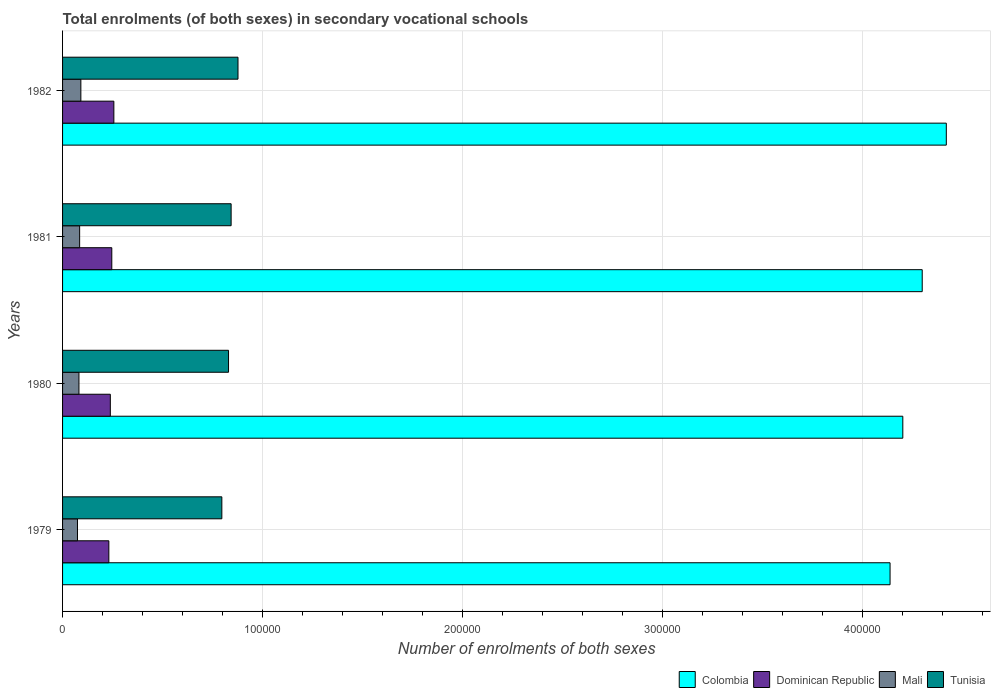Are the number of bars on each tick of the Y-axis equal?
Keep it short and to the point. Yes. How many bars are there on the 3rd tick from the top?
Your answer should be very brief. 4. What is the label of the 3rd group of bars from the top?
Provide a succinct answer. 1980. What is the number of enrolments in secondary schools in Mali in 1979?
Your answer should be very brief. 7461. Across all years, what is the maximum number of enrolments in secondary schools in Tunisia?
Your answer should be very brief. 8.77e+04. Across all years, what is the minimum number of enrolments in secondary schools in Dominican Republic?
Offer a very short reply. 2.31e+04. In which year was the number of enrolments in secondary schools in Colombia minimum?
Make the answer very short. 1979. What is the total number of enrolments in secondary schools in Mali in the graph?
Provide a succinct answer. 3.33e+04. What is the difference between the number of enrolments in secondary schools in Tunisia in 1979 and that in 1982?
Your answer should be compact. -8079. What is the difference between the number of enrolments in secondary schools in Dominican Republic in 1979 and the number of enrolments in secondary schools in Colombia in 1982?
Provide a short and direct response. -4.19e+05. What is the average number of enrolments in secondary schools in Colombia per year?
Your response must be concise. 4.26e+05. In the year 1982, what is the difference between the number of enrolments in secondary schools in Tunisia and number of enrolments in secondary schools in Colombia?
Your response must be concise. -3.54e+05. In how many years, is the number of enrolments in secondary schools in Colombia greater than 280000 ?
Ensure brevity in your answer.  4. What is the ratio of the number of enrolments in secondary schools in Mali in 1981 to that in 1982?
Offer a very short reply. 0.93. What is the difference between the highest and the second highest number of enrolments in secondary schools in Colombia?
Keep it short and to the point. 1.20e+04. What is the difference between the highest and the lowest number of enrolments in secondary schools in Tunisia?
Make the answer very short. 8079. In how many years, is the number of enrolments in secondary schools in Dominican Republic greater than the average number of enrolments in secondary schools in Dominican Republic taken over all years?
Offer a very short reply. 2. Is it the case that in every year, the sum of the number of enrolments in secondary schools in Mali and number of enrolments in secondary schools in Dominican Republic is greater than the sum of number of enrolments in secondary schools in Tunisia and number of enrolments in secondary schools in Colombia?
Provide a short and direct response. No. What does the 2nd bar from the top in 1982 represents?
Your response must be concise. Mali. What does the 2nd bar from the bottom in 1982 represents?
Offer a terse response. Dominican Republic. Is it the case that in every year, the sum of the number of enrolments in secondary schools in Tunisia and number of enrolments in secondary schools in Dominican Republic is greater than the number of enrolments in secondary schools in Mali?
Make the answer very short. Yes. Does the graph contain any zero values?
Keep it short and to the point. No. What is the title of the graph?
Make the answer very short. Total enrolments (of both sexes) in secondary vocational schools. What is the label or title of the X-axis?
Keep it short and to the point. Number of enrolments of both sexes. What is the Number of enrolments of both sexes of Colombia in 1979?
Provide a succinct answer. 4.14e+05. What is the Number of enrolments of both sexes in Dominican Republic in 1979?
Offer a very short reply. 2.31e+04. What is the Number of enrolments of both sexes of Mali in 1979?
Make the answer very short. 7461. What is the Number of enrolments of both sexes in Tunisia in 1979?
Keep it short and to the point. 7.96e+04. What is the Number of enrolments of both sexes of Colombia in 1980?
Keep it short and to the point. 4.20e+05. What is the Number of enrolments of both sexes of Dominican Republic in 1980?
Keep it short and to the point. 2.39e+04. What is the Number of enrolments of both sexes of Mali in 1980?
Give a very brief answer. 8193. What is the Number of enrolments of both sexes of Tunisia in 1980?
Ensure brevity in your answer.  8.30e+04. What is the Number of enrolments of both sexes of Colombia in 1981?
Make the answer very short. 4.30e+05. What is the Number of enrolments of both sexes in Dominican Republic in 1981?
Keep it short and to the point. 2.46e+04. What is the Number of enrolments of both sexes of Mali in 1981?
Offer a very short reply. 8537. What is the Number of enrolments of both sexes in Tunisia in 1981?
Your answer should be compact. 8.43e+04. What is the Number of enrolments of both sexes of Colombia in 1982?
Offer a terse response. 4.42e+05. What is the Number of enrolments of both sexes in Dominican Republic in 1982?
Your answer should be very brief. 2.56e+04. What is the Number of enrolments of both sexes of Mali in 1982?
Make the answer very short. 9150. What is the Number of enrolments of both sexes of Tunisia in 1982?
Provide a short and direct response. 8.77e+04. Across all years, what is the maximum Number of enrolments of both sexes in Colombia?
Ensure brevity in your answer.  4.42e+05. Across all years, what is the maximum Number of enrolments of both sexes in Dominican Republic?
Provide a succinct answer. 2.56e+04. Across all years, what is the maximum Number of enrolments of both sexes of Mali?
Offer a very short reply. 9150. Across all years, what is the maximum Number of enrolments of both sexes in Tunisia?
Your answer should be very brief. 8.77e+04. Across all years, what is the minimum Number of enrolments of both sexes in Colombia?
Provide a short and direct response. 4.14e+05. Across all years, what is the minimum Number of enrolments of both sexes in Dominican Republic?
Offer a very short reply. 2.31e+04. Across all years, what is the minimum Number of enrolments of both sexes in Mali?
Ensure brevity in your answer.  7461. Across all years, what is the minimum Number of enrolments of both sexes in Tunisia?
Your answer should be very brief. 7.96e+04. What is the total Number of enrolments of both sexes of Colombia in the graph?
Give a very brief answer. 1.71e+06. What is the total Number of enrolments of both sexes of Dominican Republic in the graph?
Keep it short and to the point. 9.73e+04. What is the total Number of enrolments of both sexes of Mali in the graph?
Ensure brevity in your answer.  3.33e+04. What is the total Number of enrolments of both sexes of Tunisia in the graph?
Your answer should be compact. 3.35e+05. What is the difference between the Number of enrolments of both sexes of Colombia in 1979 and that in 1980?
Offer a terse response. -6379. What is the difference between the Number of enrolments of both sexes in Dominican Republic in 1979 and that in 1980?
Give a very brief answer. -738. What is the difference between the Number of enrolments of both sexes of Mali in 1979 and that in 1980?
Provide a short and direct response. -732. What is the difference between the Number of enrolments of both sexes in Tunisia in 1979 and that in 1980?
Your response must be concise. -3344. What is the difference between the Number of enrolments of both sexes of Colombia in 1979 and that in 1981?
Give a very brief answer. -1.61e+04. What is the difference between the Number of enrolments of both sexes of Dominican Republic in 1979 and that in 1981?
Offer a very short reply. -1476. What is the difference between the Number of enrolments of both sexes of Mali in 1979 and that in 1981?
Make the answer very short. -1076. What is the difference between the Number of enrolments of both sexes of Tunisia in 1979 and that in 1981?
Provide a succinct answer. -4643. What is the difference between the Number of enrolments of both sexes in Colombia in 1979 and that in 1982?
Offer a terse response. -2.81e+04. What is the difference between the Number of enrolments of both sexes in Dominican Republic in 1979 and that in 1982?
Keep it short and to the point. -2504. What is the difference between the Number of enrolments of both sexes of Mali in 1979 and that in 1982?
Your response must be concise. -1689. What is the difference between the Number of enrolments of both sexes in Tunisia in 1979 and that in 1982?
Your response must be concise. -8079. What is the difference between the Number of enrolments of both sexes in Colombia in 1980 and that in 1981?
Offer a terse response. -9705. What is the difference between the Number of enrolments of both sexes in Dominican Republic in 1980 and that in 1981?
Provide a short and direct response. -738. What is the difference between the Number of enrolments of both sexes in Mali in 1980 and that in 1981?
Your answer should be very brief. -344. What is the difference between the Number of enrolments of both sexes of Tunisia in 1980 and that in 1981?
Provide a succinct answer. -1299. What is the difference between the Number of enrolments of both sexes of Colombia in 1980 and that in 1982?
Your answer should be compact. -2.17e+04. What is the difference between the Number of enrolments of both sexes in Dominican Republic in 1980 and that in 1982?
Ensure brevity in your answer.  -1766. What is the difference between the Number of enrolments of both sexes of Mali in 1980 and that in 1982?
Provide a succinct answer. -957. What is the difference between the Number of enrolments of both sexes in Tunisia in 1980 and that in 1982?
Your answer should be compact. -4735. What is the difference between the Number of enrolments of both sexes of Colombia in 1981 and that in 1982?
Offer a terse response. -1.20e+04. What is the difference between the Number of enrolments of both sexes in Dominican Republic in 1981 and that in 1982?
Ensure brevity in your answer.  -1028. What is the difference between the Number of enrolments of both sexes of Mali in 1981 and that in 1982?
Offer a terse response. -613. What is the difference between the Number of enrolments of both sexes in Tunisia in 1981 and that in 1982?
Your answer should be very brief. -3436. What is the difference between the Number of enrolments of both sexes of Colombia in 1979 and the Number of enrolments of both sexes of Dominican Republic in 1980?
Offer a terse response. 3.90e+05. What is the difference between the Number of enrolments of both sexes in Colombia in 1979 and the Number of enrolments of both sexes in Mali in 1980?
Offer a terse response. 4.06e+05. What is the difference between the Number of enrolments of both sexes of Colombia in 1979 and the Number of enrolments of both sexes of Tunisia in 1980?
Provide a short and direct response. 3.31e+05. What is the difference between the Number of enrolments of both sexes in Dominican Republic in 1979 and the Number of enrolments of both sexes in Mali in 1980?
Provide a short and direct response. 1.50e+04. What is the difference between the Number of enrolments of both sexes in Dominican Republic in 1979 and the Number of enrolments of both sexes in Tunisia in 1980?
Your answer should be very brief. -5.98e+04. What is the difference between the Number of enrolments of both sexes in Mali in 1979 and the Number of enrolments of both sexes in Tunisia in 1980?
Give a very brief answer. -7.55e+04. What is the difference between the Number of enrolments of both sexes of Colombia in 1979 and the Number of enrolments of both sexes of Dominican Republic in 1981?
Provide a succinct answer. 3.89e+05. What is the difference between the Number of enrolments of both sexes of Colombia in 1979 and the Number of enrolments of both sexes of Mali in 1981?
Keep it short and to the point. 4.05e+05. What is the difference between the Number of enrolments of both sexes in Colombia in 1979 and the Number of enrolments of both sexes in Tunisia in 1981?
Offer a very short reply. 3.30e+05. What is the difference between the Number of enrolments of both sexes of Dominican Republic in 1979 and the Number of enrolments of both sexes of Mali in 1981?
Provide a short and direct response. 1.46e+04. What is the difference between the Number of enrolments of both sexes in Dominican Republic in 1979 and the Number of enrolments of both sexes in Tunisia in 1981?
Your answer should be compact. -6.11e+04. What is the difference between the Number of enrolments of both sexes of Mali in 1979 and the Number of enrolments of both sexes of Tunisia in 1981?
Keep it short and to the point. -7.68e+04. What is the difference between the Number of enrolments of both sexes of Colombia in 1979 and the Number of enrolments of both sexes of Dominican Republic in 1982?
Give a very brief answer. 3.88e+05. What is the difference between the Number of enrolments of both sexes of Colombia in 1979 and the Number of enrolments of both sexes of Mali in 1982?
Provide a succinct answer. 4.05e+05. What is the difference between the Number of enrolments of both sexes in Colombia in 1979 and the Number of enrolments of both sexes in Tunisia in 1982?
Make the answer very short. 3.26e+05. What is the difference between the Number of enrolments of both sexes of Dominican Republic in 1979 and the Number of enrolments of both sexes of Mali in 1982?
Offer a terse response. 1.40e+04. What is the difference between the Number of enrolments of both sexes in Dominican Republic in 1979 and the Number of enrolments of both sexes in Tunisia in 1982?
Keep it short and to the point. -6.46e+04. What is the difference between the Number of enrolments of both sexes in Mali in 1979 and the Number of enrolments of both sexes in Tunisia in 1982?
Provide a succinct answer. -8.03e+04. What is the difference between the Number of enrolments of both sexes in Colombia in 1980 and the Number of enrolments of both sexes in Dominican Republic in 1981?
Provide a short and direct response. 3.96e+05. What is the difference between the Number of enrolments of both sexes in Colombia in 1980 and the Number of enrolments of both sexes in Mali in 1981?
Your answer should be compact. 4.12e+05. What is the difference between the Number of enrolments of both sexes of Colombia in 1980 and the Number of enrolments of both sexes of Tunisia in 1981?
Offer a terse response. 3.36e+05. What is the difference between the Number of enrolments of both sexes of Dominican Republic in 1980 and the Number of enrolments of both sexes of Mali in 1981?
Offer a very short reply. 1.53e+04. What is the difference between the Number of enrolments of both sexes of Dominican Republic in 1980 and the Number of enrolments of both sexes of Tunisia in 1981?
Your answer should be compact. -6.04e+04. What is the difference between the Number of enrolments of both sexes of Mali in 1980 and the Number of enrolments of both sexes of Tunisia in 1981?
Provide a short and direct response. -7.61e+04. What is the difference between the Number of enrolments of both sexes of Colombia in 1980 and the Number of enrolments of both sexes of Dominican Republic in 1982?
Give a very brief answer. 3.95e+05. What is the difference between the Number of enrolments of both sexes of Colombia in 1980 and the Number of enrolments of both sexes of Mali in 1982?
Make the answer very short. 4.11e+05. What is the difference between the Number of enrolments of both sexes in Colombia in 1980 and the Number of enrolments of both sexes in Tunisia in 1982?
Keep it short and to the point. 3.32e+05. What is the difference between the Number of enrolments of both sexes in Dominican Republic in 1980 and the Number of enrolments of both sexes in Mali in 1982?
Keep it short and to the point. 1.47e+04. What is the difference between the Number of enrolments of both sexes in Dominican Republic in 1980 and the Number of enrolments of both sexes in Tunisia in 1982?
Your answer should be compact. -6.38e+04. What is the difference between the Number of enrolments of both sexes of Mali in 1980 and the Number of enrolments of both sexes of Tunisia in 1982?
Offer a terse response. -7.95e+04. What is the difference between the Number of enrolments of both sexes of Colombia in 1981 and the Number of enrolments of both sexes of Dominican Republic in 1982?
Provide a succinct answer. 4.04e+05. What is the difference between the Number of enrolments of both sexes in Colombia in 1981 and the Number of enrolments of both sexes in Mali in 1982?
Offer a terse response. 4.21e+05. What is the difference between the Number of enrolments of both sexes in Colombia in 1981 and the Number of enrolments of both sexes in Tunisia in 1982?
Keep it short and to the point. 3.42e+05. What is the difference between the Number of enrolments of both sexes of Dominican Republic in 1981 and the Number of enrolments of both sexes of Mali in 1982?
Give a very brief answer. 1.55e+04. What is the difference between the Number of enrolments of both sexes of Dominican Republic in 1981 and the Number of enrolments of both sexes of Tunisia in 1982?
Provide a short and direct response. -6.31e+04. What is the difference between the Number of enrolments of both sexes in Mali in 1981 and the Number of enrolments of both sexes in Tunisia in 1982?
Provide a succinct answer. -7.92e+04. What is the average Number of enrolments of both sexes of Colombia per year?
Your answer should be very brief. 4.26e+05. What is the average Number of enrolments of both sexes of Dominican Republic per year?
Your answer should be very brief. 2.43e+04. What is the average Number of enrolments of both sexes in Mali per year?
Provide a succinct answer. 8335.25. What is the average Number of enrolments of both sexes of Tunisia per year?
Give a very brief answer. 8.37e+04. In the year 1979, what is the difference between the Number of enrolments of both sexes of Colombia and Number of enrolments of both sexes of Dominican Republic?
Provide a short and direct response. 3.91e+05. In the year 1979, what is the difference between the Number of enrolments of both sexes in Colombia and Number of enrolments of both sexes in Mali?
Your answer should be compact. 4.06e+05. In the year 1979, what is the difference between the Number of enrolments of both sexes in Colombia and Number of enrolments of both sexes in Tunisia?
Offer a very short reply. 3.34e+05. In the year 1979, what is the difference between the Number of enrolments of both sexes of Dominican Republic and Number of enrolments of both sexes of Mali?
Give a very brief answer. 1.57e+04. In the year 1979, what is the difference between the Number of enrolments of both sexes in Dominican Republic and Number of enrolments of both sexes in Tunisia?
Keep it short and to the point. -5.65e+04. In the year 1979, what is the difference between the Number of enrolments of both sexes in Mali and Number of enrolments of both sexes in Tunisia?
Keep it short and to the point. -7.22e+04. In the year 1980, what is the difference between the Number of enrolments of both sexes in Colombia and Number of enrolments of both sexes in Dominican Republic?
Keep it short and to the point. 3.96e+05. In the year 1980, what is the difference between the Number of enrolments of both sexes of Colombia and Number of enrolments of both sexes of Mali?
Provide a short and direct response. 4.12e+05. In the year 1980, what is the difference between the Number of enrolments of both sexes of Colombia and Number of enrolments of both sexes of Tunisia?
Give a very brief answer. 3.37e+05. In the year 1980, what is the difference between the Number of enrolments of both sexes in Dominican Republic and Number of enrolments of both sexes in Mali?
Your answer should be compact. 1.57e+04. In the year 1980, what is the difference between the Number of enrolments of both sexes of Dominican Republic and Number of enrolments of both sexes of Tunisia?
Give a very brief answer. -5.91e+04. In the year 1980, what is the difference between the Number of enrolments of both sexes of Mali and Number of enrolments of both sexes of Tunisia?
Keep it short and to the point. -7.48e+04. In the year 1981, what is the difference between the Number of enrolments of both sexes in Colombia and Number of enrolments of both sexes in Dominican Republic?
Provide a succinct answer. 4.05e+05. In the year 1981, what is the difference between the Number of enrolments of both sexes in Colombia and Number of enrolments of both sexes in Mali?
Offer a very short reply. 4.21e+05. In the year 1981, what is the difference between the Number of enrolments of both sexes in Colombia and Number of enrolments of both sexes in Tunisia?
Ensure brevity in your answer.  3.46e+05. In the year 1981, what is the difference between the Number of enrolments of both sexes of Dominican Republic and Number of enrolments of both sexes of Mali?
Ensure brevity in your answer.  1.61e+04. In the year 1981, what is the difference between the Number of enrolments of both sexes in Dominican Republic and Number of enrolments of both sexes in Tunisia?
Provide a short and direct response. -5.97e+04. In the year 1981, what is the difference between the Number of enrolments of both sexes of Mali and Number of enrolments of both sexes of Tunisia?
Your response must be concise. -7.58e+04. In the year 1982, what is the difference between the Number of enrolments of both sexes in Colombia and Number of enrolments of both sexes in Dominican Republic?
Make the answer very short. 4.16e+05. In the year 1982, what is the difference between the Number of enrolments of both sexes of Colombia and Number of enrolments of both sexes of Mali?
Give a very brief answer. 4.33e+05. In the year 1982, what is the difference between the Number of enrolments of both sexes in Colombia and Number of enrolments of both sexes in Tunisia?
Offer a terse response. 3.54e+05. In the year 1982, what is the difference between the Number of enrolments of both sexes of Dominican Republic and Number of enrolments of both sexes of Mali?
Provide a short and direct response. 1.65e+04. In the year 1982, what is the difference between the Number of enrolments of both sexes in Dominican Republic and Number of enrolments of both sexes in Tunisia?
Offer a very short reply. -6.21e+04. In the year 1982, what is the difference between the Number of enrolments of both sexes of Mali and Number of enrolments of both sexes of Tunisia?
Offer a very short reply. -7.86e+04. What is the ratio of the Number of enrolments of both sexes in Colombia in 1979 to that in 1980?
Provide a short and direct response. 0.98. What is the ratio of the Number of enrolments of both sexes of Dominican Republic in 1979 to that in 1980?
Your response must be concise. 0.97. What is the ratio of the Number of enrolments of both sexes of Mali in 1979 to that in 1980?
Provide a succinct answer. 0.91. What is the ratio of the Number of enrolments of both sexes in Tunisia in 1979 to that in 1980?
Ensure brevity in your answer.  0.96. What is the ratio of the Number of enrolments of both sexes in Colombia in 1979 to that in 1981?
Offer a very short reply. 0.96. What is the ratio of the Number of enrolments of both sexes of Mali in 1979 to that in 1981?
Ensure brevity in your answer.  0.87. What is the ratio of the Number of enrolments of both sexes in Tunisia in 1979 to that in 1981?
Offer a very short reply. 0.94. What is the ratio of the Number of enrolments of both sexes in Colombia in 1979 to that in 1982?
Offer a terse response. 0.94. What is the ratio of the Number of enrolments of both sexes of Dominican Republic in 1979 to that in 1982?
Your answer should be very brief. 0.9. What is the ratio of the Number of enrolments of both sexes of Mali in 1979 to that in 1982?
Your answer should be very brief. 0.82. What is the ratio of the Number of enrolments of both sexes in Tunisia in 1979 to that in 1982?
Offer a very short reply. 0.91. What is the ratio of the Number of enrolments of both sexes in Colombia in 1980 to that in 1981?
Make the answer very short. 0.98. What is the ratio of the Number of enrolments of both sexes in Dominican Republic in 1980 to that in 1981?
Your response must be concise. 0.97. What is the ratio of the Number of enrolments of both sexes of Mali in 1980 to that in 1981?
Provide a short and direct response. 0.96. What is the ratio of the Number of enrolments of both sexes of Tunisia in 1980 to that in 1981?
Make the answer very short. 0.98. What is the ratio of the Number of enrolments of both sexes of Colombia in 1980 to that in 1982?
Provide a short and direct response. 0.95. What is the ratio of the Number of enrolments of both sexes of Dominican Republic in 1980 to that in 1982?
Your answer should be compact. 0.93. What is the ratio of the Number of enrolments of both sexes of Mali in 1980 to that in 1982?
Provide a succinct answer. 0.9. What is the ratio of the Number of enrolments of both sexes in Tunisia in 1980 to that in 1982?
Your response must be concise. 0.95. What is the ratio of the Number of enrolments of both sexes of Colombia in 1981 to that in 1982?
Provide a short and direct response. 0.97. What is the ratio of the Number of enrolments of both sexes of Dominican Republic in 1981 to that in 1982?
Give a very brief answer. 0.96. What is the ratio of the Number of enrolments of both sexes of Mali in 1981 to that in 1982?
Keep it short and to the point. 0.93. What is the ratio of the Number of enrolments of both sexes in Tunisia in 1981 to that in 1982?
Provide a short and direct response. 0.96. What is the difference between the highest and the second highest Number of enrolments of both sexes of Colombia?
Offer a terse response. 1.20e+04. What is the difference between the highest and the second highest Number of enrolments of both sexes of Dominican Republic?
Your answer should be very brief. 1028. What is the difference between the highest and the second highest Number of enrolments of both sexes of Mali?
Give a very brief answer. 613. What is the difference between the highest and the second highest Number of enrolments of both sexes in Tunisia?
Give a very brief answer. 3436. What is the difference between the highest and the lowest Number of enrolments of both sexes in Colombia?
Make the answer very short. 2.81e+04. What is the difference between the highest and the lowest Number of enrolments of both sexes in Dominican Republic?
Give a very brief answer. 2504. What is the difference between the highest and the lowest Number of enrolments of both sexes in Mali?
Make the answer very short. 1689. What is the difference between the highest and the lowest Number of enrolments of both sexes of Tunisia?
Your answer should be compact. 8079. 